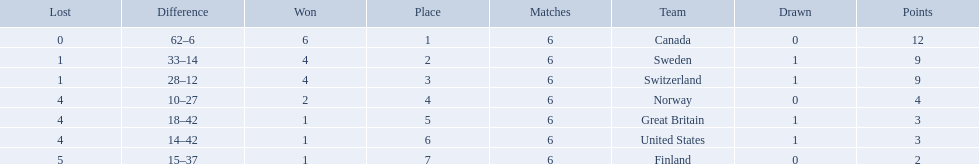What are all the teams? Canada, Sweden, Switzerland, Norway, Great Britain, United States, Finland. What were their points? 12, 9, 9, 4, 3, 3, 2. What about just switzerland and great britain? 9, 3. Now, which of those teams scored higher? Switzerland. 